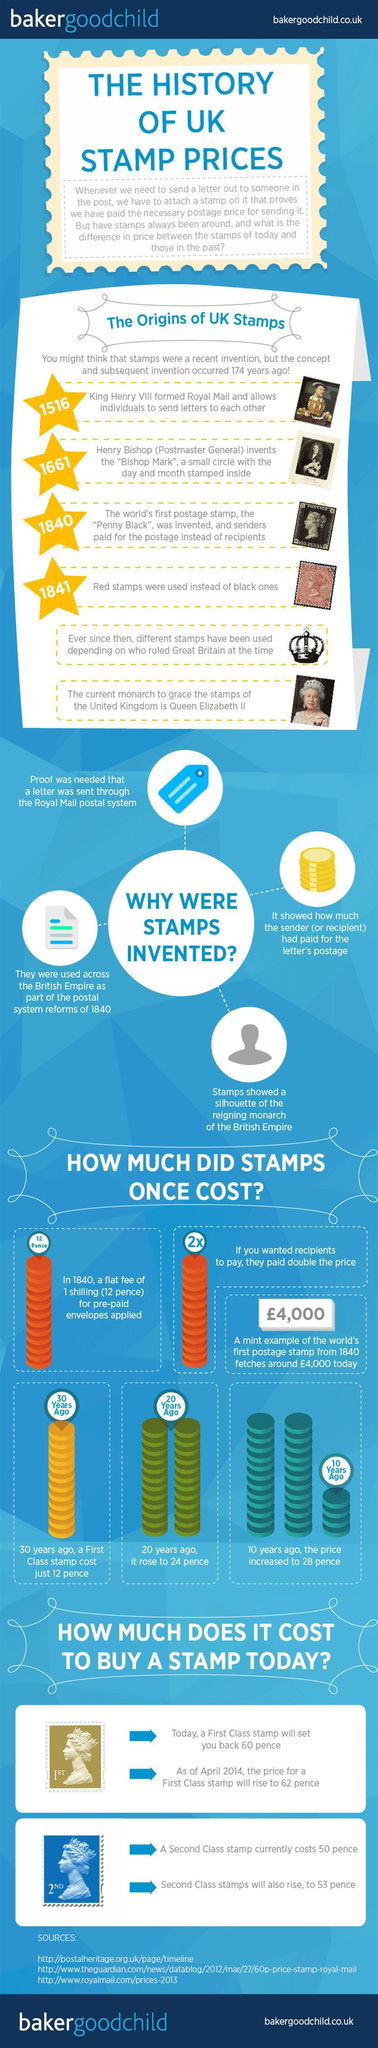In which year was Penny Black introduced?
Answer the question with a short phrase. 1840 How many sources are listed at the bottom? 3 Whose face is on UK's stamps presently? Queen Elizabeth II 